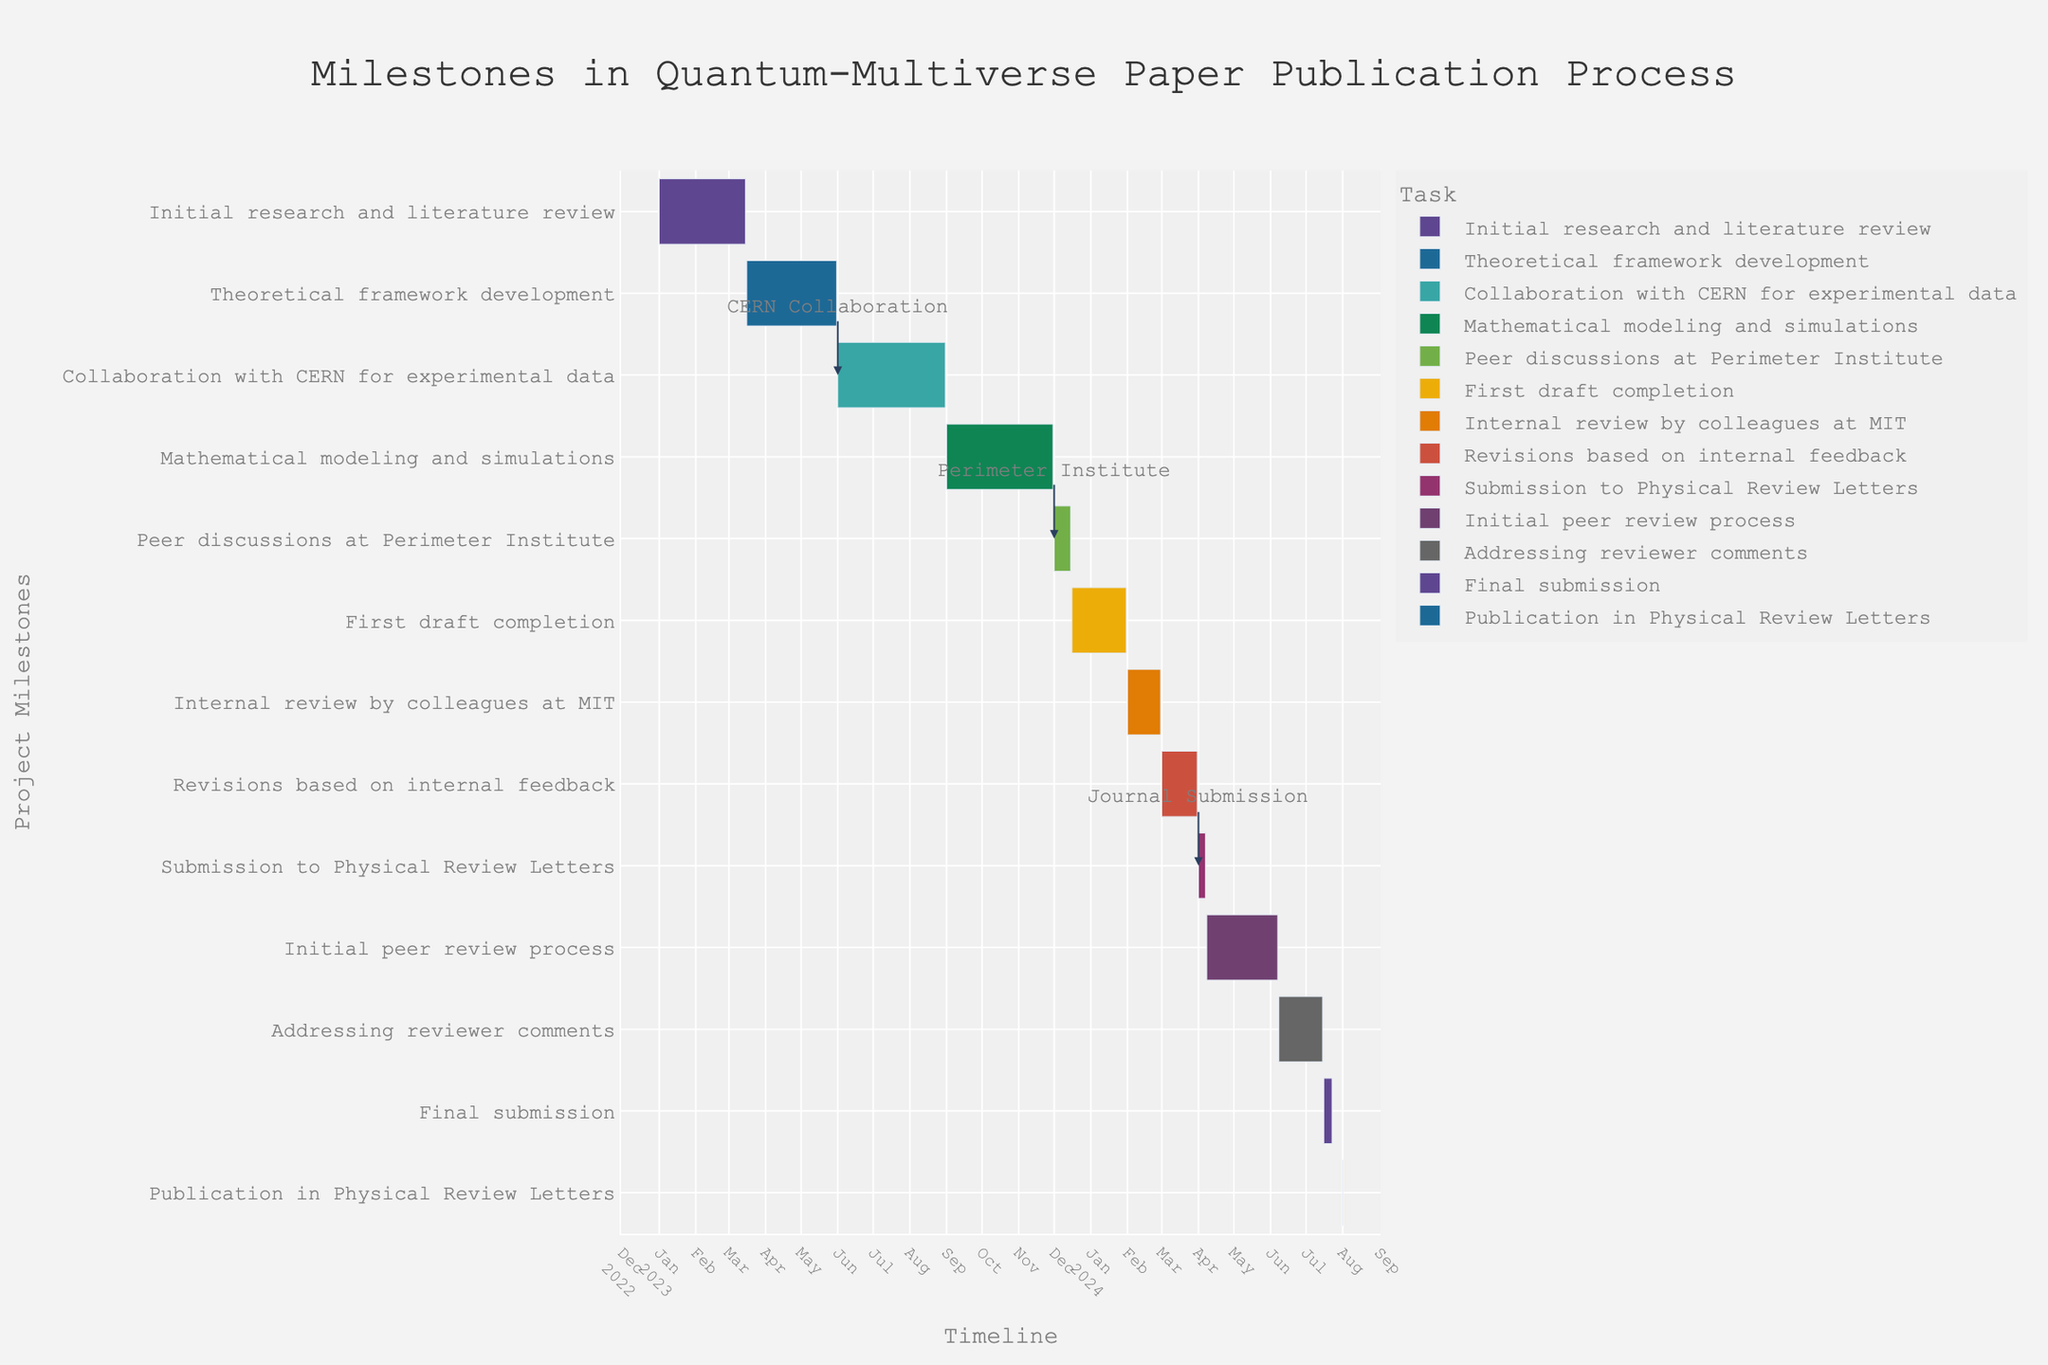What is the title of the Gantt Chart? The title is usually found at the top of the chart. In this figure, the title is "Milestones in Quantum-Multiverse Paper Publication Process."
Answer: Milestones in Quantum-Multiverse Paper Publication Process Which task has the shortest duration? By observing the length of the bars, "Publication in Physical Review Letters" is significantly shorter than others, lasting only one day.
Answer: Publication in Physical Review Letters During which months was the "Collaboration with CERN for experimental data" conducted? The task "Collaboration with CERN for experimental data" starts in June and ends in August, as shown on the timeline.
Answer: June to August 2023 How long did the "Initial research and literature review" take? By checking the start and end dates, the task began on January 1, 2023, and ended on March 15, 2023. To find the duration, calculate the difference between the end and start dates.
Answer: 73 days Which tasks are annotated with descriptions in the figure? The annotations for key events are visible in the figure; they are "Collaboration with CERN for experimental data," "Peer discussions at Perimeter Institute," and "Submission to Physical Review Letters."
Answer: Collaboration with CERN for experimental data, Peer discussions at Perimeter Institute, Submission to Physical Review Letters Which task directly follows "Collaboration with CERN for experimental data"? Observing the sequence, "Mathematical modeling and simulations" starts immediately after "Collaboration with CERN for experimental data."
Answer: Mathematical modeling and simulations What is the total duration from the "First draft completion" to the "Publication in Physical Review Letters"? The period starts on December 16, 2023, and ends on August 1, 2024. Calculate the total duration between these dates.
Answer: 229 days Which milestone involves engagement at the Perimeter Institute? The task named "Peer discussions at Perimeter Institute" involves engagement at the Perimeter Institute, which is indicated by its name.
Answer: Peer discussions at Perimeter Institute Compare the duration of "Initial peer review process" with "Internal review by colleagues at MIT." Which one is longer, and by how many days? The "Initial peer review process" lasts from April 8 to June 7, 2024 (60 days), while the "Internal review by colleagues at MIT" lasts from February 1 to February 29 (28 days). The peer review process is longer by the difference in duration.
Answer: Initial peer review process is longer by 32 days What is the order of tasks from "Mathematical modeling and simulations" to "First draft completion"? The tasks need to be listed in sequence starting from "Mathematical modeling and simulations" leading to "First draft completion." From the figure: "Mathematical modeling and simulations," "Peer discussions at Perimeter Institute," "First draft completion."
Answer: Mathematical modeling and simulations, Peer discussions at Perimeter Institute, First draft completion 